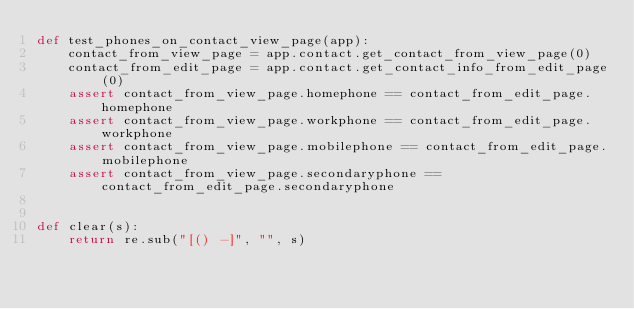<code> <loc_0><loc_0><loc_500><loc_500><_Python_>def test_phones_on_contact_view_page(app):
    contact_from_view_page = app.contact.get_contact_from_view_page(0)
    contact_from_edit_page = app.contact.get_contact_info_from_edit_page(0)
    assert contact_from_view_page.homephone == contact_from_edit_page.homephone
    assert contact_from_view_page.workphone == contact_from_edit_page.workphone
    assert contact_from_view_page.mobilephone == contact_from_edit_page.mobilephone
    assert contact_from_view_page.secondaryphone == contact_from_edit_page.secondaryphone


def clear(s):
    return re.sub("[() -]", "", s)
</code> 